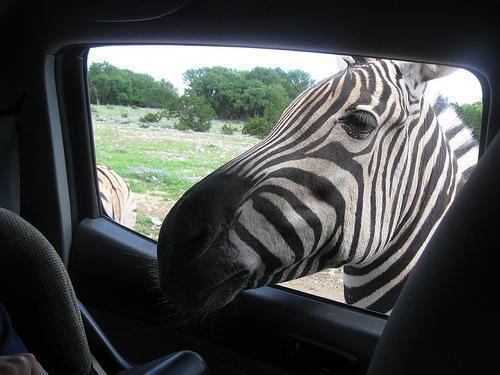How many zebras are in the image?
Give a very brief answer. 2. 